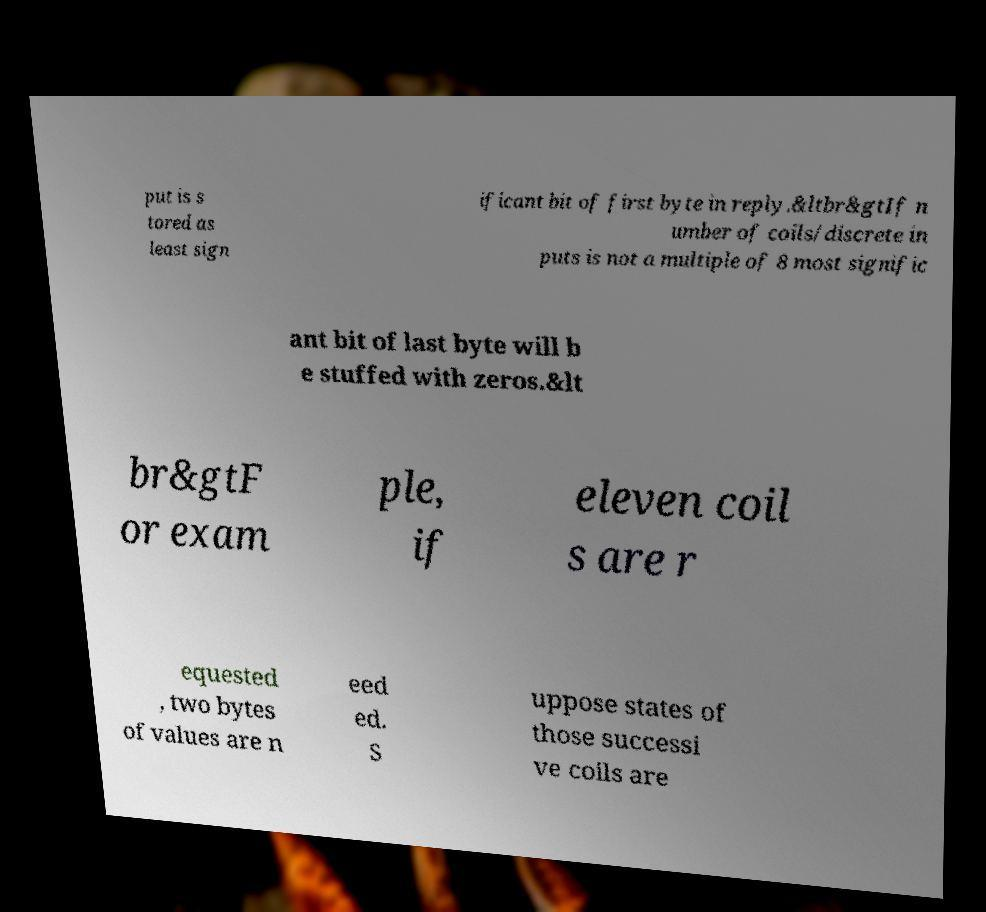Could you extract and type out the text from this image? put is s tored as least sign ificant bit of first byte in reply.&ltbr&gtIf n umber of coils/discrete in puts is not a multiple of 8 most signific ant bit of last byte will b e stuffed with zeros.&lt br&gtF or exam ple, if eleven coil s are r equested , two bytes of values are n eed ed. S uppose states of those successi ve coils are 